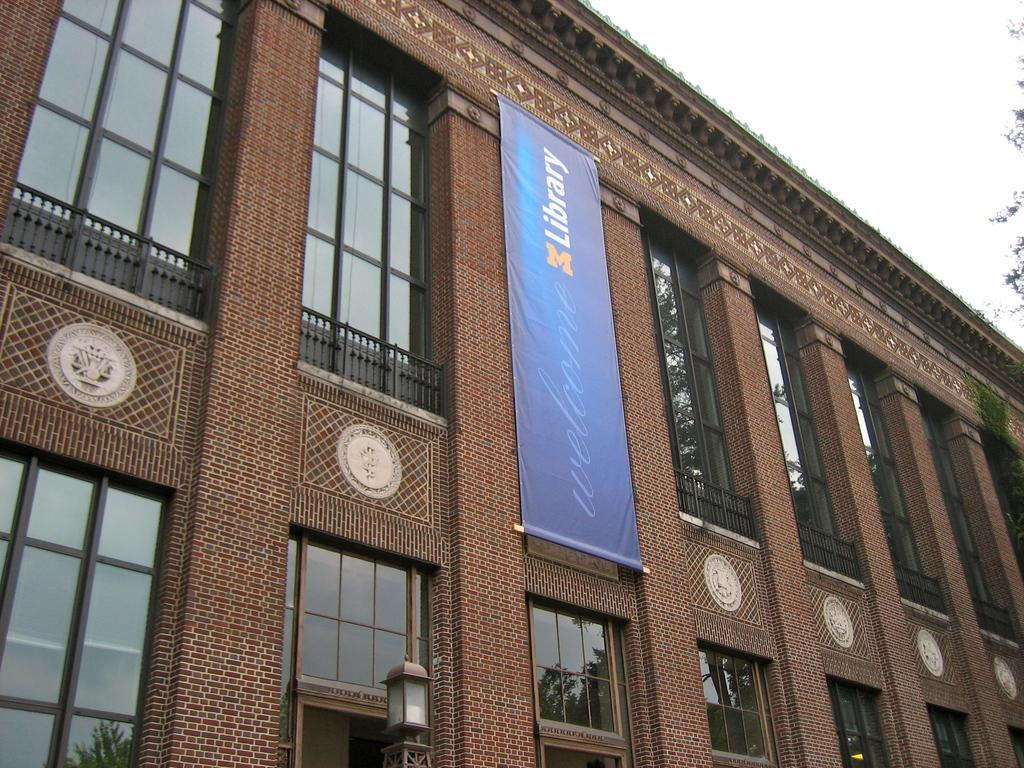Provide a one-sentence caption for the provided image. The library is a brick building with a blue banner on it. 